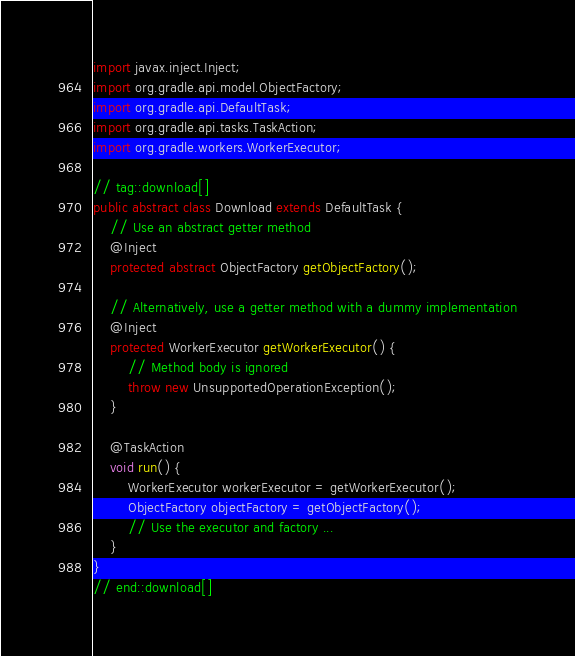<code> <loc_0><loc_0><loc_500><loc_500><_Java_>import javax.inject.Inject;
import org.gradle.api.model.ObjectFactory;
import org.gradle.api.DefaultTask;
import org.gradle.api.tasks.TaskAction;
import org.gradle.workers.WorkerExecutor;

// tag::download[]
public abstract class Download extends DefaultTask {
    // Use an abstract getter method
    @Inject
    protected abstract ObjectFactory getObjectFactory();

    // Alternatively, use a getter method with a dummy implementation
    @Inject
    protected WorkerExecutor getWorkerExecutor() {
        // Method body is ignored
        throw new UnsupportedOperationException();
    }

    @TaskAction
    void run() {
        WorkerExecutor workerExecutor = getWorkerExecutor();
        ObjectFactory objectFactory = getObjectFactory();
        // Use the executor and factory ...
    }
}
// end::download[]
</code> 